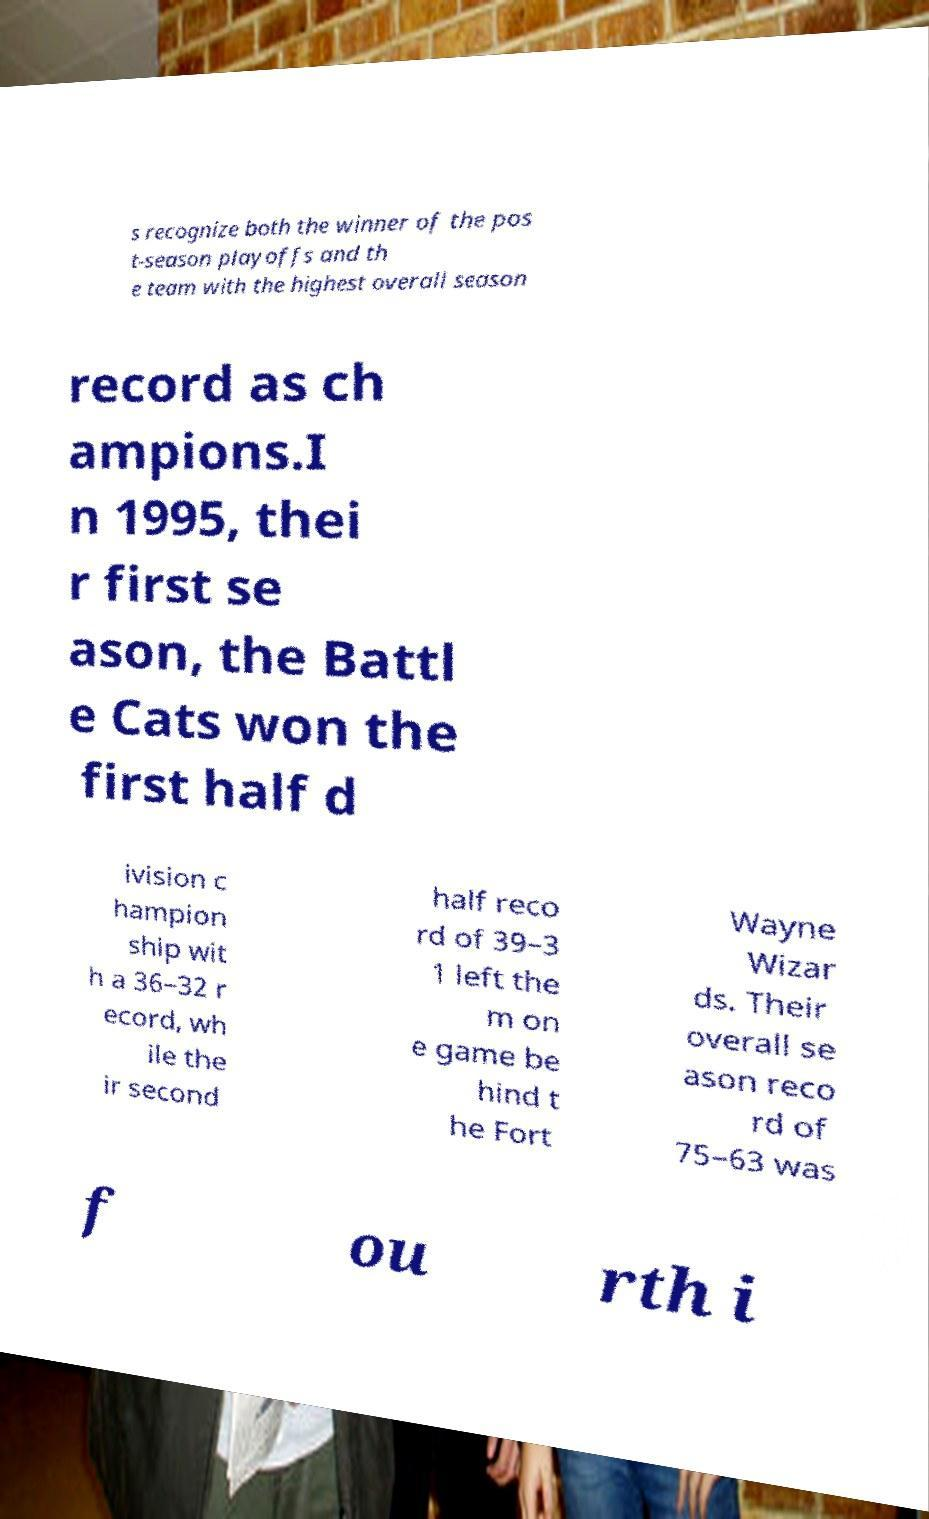For documentation purposes, I need the text within this image transcribed. Could you provide that? s recognize both the winner of the pos t-season playoffs and th e team with the highest overall season record as ch ampions.I n 1995, thei r first se ason, the Battl e Cats won the first half d ivision c hampion ship wit h a 36–32 r ecord, wh ile the ir second half reco rd of 39–3 1 left the m on e game be hind t he Fort Wayne Wizar ds. Their overall se ason reco rd of 75–63 was f ou rth i 